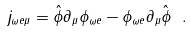<formula> <loc_0><loc_0><loc_500><loc_500>j _ { { \omega { e } } \mu } = \hat { \phi } \partial _ { \mu } \phi _ { \omega { e } } - \phi _ { { \omega { e } } } \partial _ { \mu } \hat { \phi } \ .</formula> 